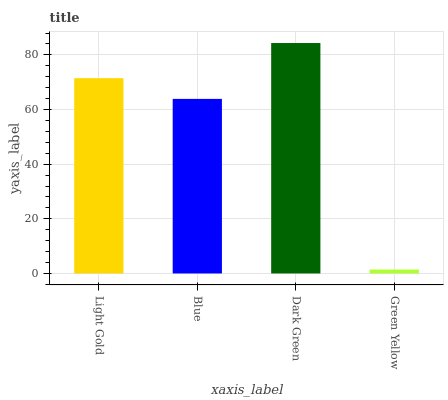Is Green Yellow the minimum?
Answer yes or no. Yes. Is Dark Green the maximum?
Answer yes or no. Yes. Is Blue the minimum?
Answer yes or no. No. Is Blue the maximum?
Answer yes or no. No. Is Light Gold greater than Blue?
Answer yes or no. Yes. Is Blue less than Light Gold?
Answer yes or no. Yes. Is Blue greater than Light Gold?
Answer yes or no. No. Is Light Gold less than Blue?
Answer yes or no. No. Is Light Gold the high median?
Answer yes or no. Yes. Is Blue the low median?
Answer yes or no. Yes. Is Dark Green the high median?
Answer yes or no. No. Is Green Yellow the low median?
Answer yes or no. No. 